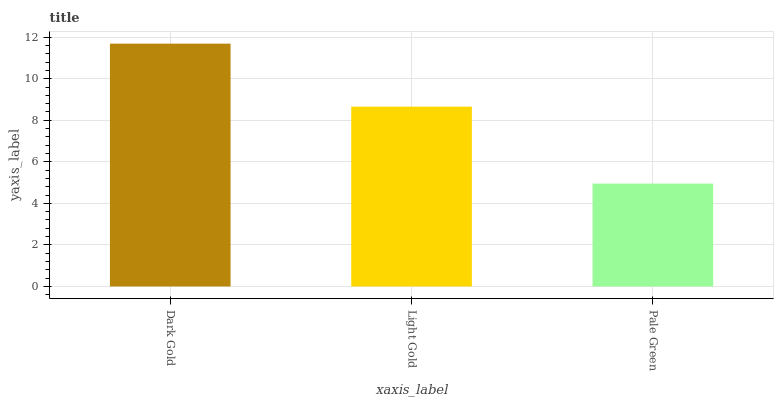Is Pale Green the minimum?
Answer yes or no. Yes. Is Dark Gold the maximum?
Answer yes or no. Yes. Is Light Gold the minimum?
Answer yes or no. No. Is Light Gold the maximum?
Answer yes or no. No. Is Dark Gold greater than Light Gold?
Answer yes or no. Yes. Is Light Gold less than Dark Gold?
Answer yes or no. Yes. Is Light Gold greater than Dark Gold?
Answer yes or no. No. Is Dark Gold less than Light Gold?
Answer yes or no. No. Is Light Gold the high median?
Answer yes or no. Yes. Is Light Gold the low median?
Answer yes or no. Yes. Is Pale Green the high median?
Answer yes or no. No. Is Pale Green the low median?
Answer yes or no. No. 